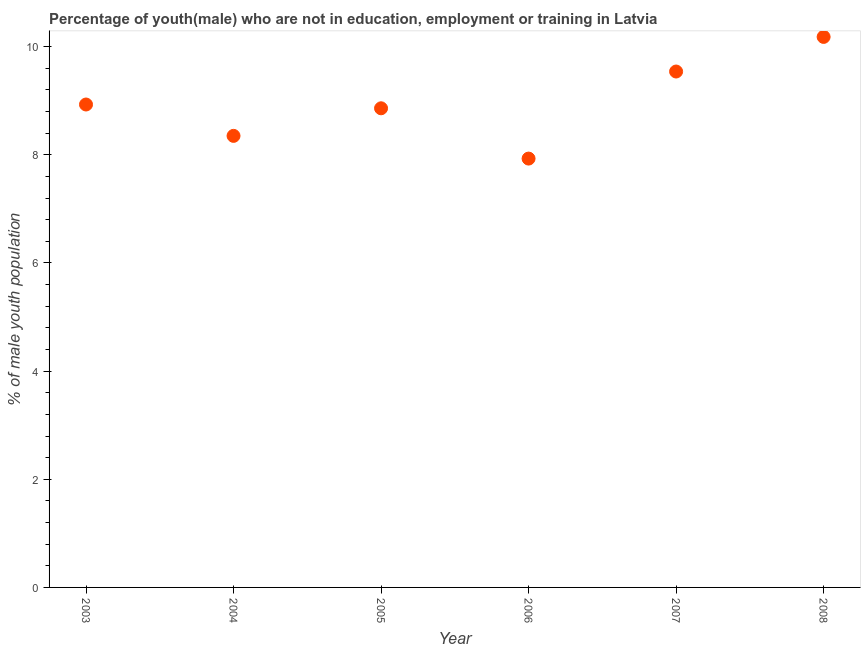What is the unemployed male youth population in 2007?
Offer a terse response. 9.54. Across all years, what is the maximum unemployed male youth population?
Ensure brevity in your answer.  10.18. Across all years, what is the minimum unemployed male youth population?
Provide a succinct answer. 7.93. What is the sum of the unemployed male youth population?
Ensure brevity in your answer.  53.79. What is the difference between the unemployed male youth population in 2006 and 2007?
Offer a terse response. -1.61. What is the average unemployed male youth population per year?
Give a very brief answer. 8.97. What is the median unemployed male youth population?
Make the answer very short. 8.89. What is the ratio of the unemployed male youth population in 2004 to that in 2008?
Your response must be concise. 0.82. Is the unemployed male youth population in 2006 less than that in 2008?
Offer a very short reply. Yes. What is the difference between the highest and the second highest unemployed male youth population?
Ensure brevity in your answer.  0.64. Is the sum of the unemployed male youth population in 2007 and 2008 greater than the maximum unemployed male youth population across all years?
Offer a terse response. Yes. What is the difference between the highest and the lowest unemployed male youth population?
Offer a very short reply. 2.25. Does the unemployed male youth population monotonically increase over the years?
Keep it short and to the point. No. How many dotlines are there?
Offer a terse response. 1. How many years are there in the graph?
Offer a very short reply. 6. What is the difference between two consecutive major ticks on the Y-axis?
Offer a very short reply. 2. Does the graph contain grids?
Ensure brevity in your answer.  No. What is the title of the graph?
Give a very brief answer. Percentage of youth(male) who are not in education, employment or training in Latvia. What is the label or title of the Y-axis?
Make the answer very short. % of male youth population. What is the % of male youth population in 2003?
Give a very brief answer. 8.93. What is the % of male youth population in 2004?
Make the answer very short. 8.35. What is the % of male youth population in 2005?
Offer a very short reply. 8.86. What is the % of male youth population in 2006?
Provide a succinct answer. 7.93. What is the % of male youth population in 2007?
Offer a terse response. 9.54. What is the % of male youth population in 2008?
Your answer should be very brief. 10.18. What is the difference between the % of male youth population in 2003 and 2004?
Offer a terse response. 0.58. What is the difference between the % of male youth population in 2003 and 2005?
Your answer should be very brief. 0.07. What is the difference between the % of male youth population in 2003 and 2006?
Your answer should be very brief. 1. What is the difference between the % of male youth population in 2003 and 2007?
Your answer should be compact. -0.61. What is the difference between the % of male youth population in 2003 and 2008?
Your response must be concise. -1.25. What is the difference between the % of male youth population in 2004 and 2005?
Offer a very short reply. -0.51. What is the difference between the % of male youth population in 2004 and 2006?
Your answer should be compact. 0.42. What is the difference between the % of male youth population in 2004 and 2007?
Ensure brevity in your answer.  -1.19. What is the difference between the % of male youth population in 2004 and 2008?
Give a very brief answer. -1.83. What is the difference between the % of male youth population in 2005 and 2007?
Offer a terse response. -0.68. What is the difference between the % of male youth population in 2005 and 2008?
Offer a very short reply. -1.32. What is the difference between the % of male youth population in 2006 and 2007?
Your response must be concise. -1.61. What is the difference between the % of male youth population in 2006 and 2008?
Your answer should be very brief. -2.25. What is the difference between the % of male youth population in 2007 and 2008?
Keep it short and to the point. -0.64. What is the ratio of the % of male youth population in 2003 to that in 2004?
Make the answer very short. 1.07. What is the ratio of the % of male youth population in 2003 to that in 2005?
Provide a succinct answer. 1.01. What is the ratio of the % of male youth population in 2003 to that in 2006?
Your answer should be very brief. 1.13. What is the ratio of the % of male youth population in 2003 to that in 2007?
Give a very brief answer. 0.94. What is the ratio of the % of male youth population in 2003 to that in 2008?
Ensure brevity in your answer.  0.88. What is the ratio of the % of male youth population in 2004 to that in 2005?
Give a very brief answer. 0.94. What is the ratio of the % of male youth population in 2004 to that in 2006?
Make the answer very short. 1.05. What is the ratio of the % of male youth population in 2004 to that in 2007?
Your response must be concise. 0.88. What is the ratio of the % of male youth population in 2004 to that in 2008?
Keep it short and to the point. 0.82. What is the ratio of the % of male youth population in 2005 to that in 2006?
Offer a terse response. 1.12. What is the ratio of the % of male youth population in 2005 to that in 2007?
Offer a terse response. 0.93. What is the ratio of the % of male youth population in 2005 to that in 2008?
Provide a succinct answer. 0.87. What is the ratio of the % of male youth population in 2006 to that in 2007?
Keep it short and to the point. 0.83. What is the ratio of the % of male youth population in 2006 to that in 2008?
Make the answer very short. 0.78. What is the ratio of the % of male youth population in 2007 to that in 2008?
Provide a succinct answer. 0.94. 